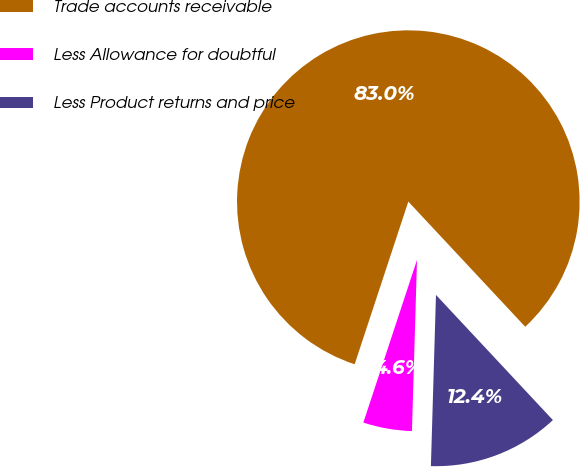Convert chart. <chart><loc_0><loc_0><loc_500><loc_500><pie_chart><fcel>Trade accounts receivable<fcel>Less Allowance for doubtful<fcel>Less Product returns and price<nl><fcel>82.97%<fcel>4.6%<fcel>12.43%<nl></chart> 